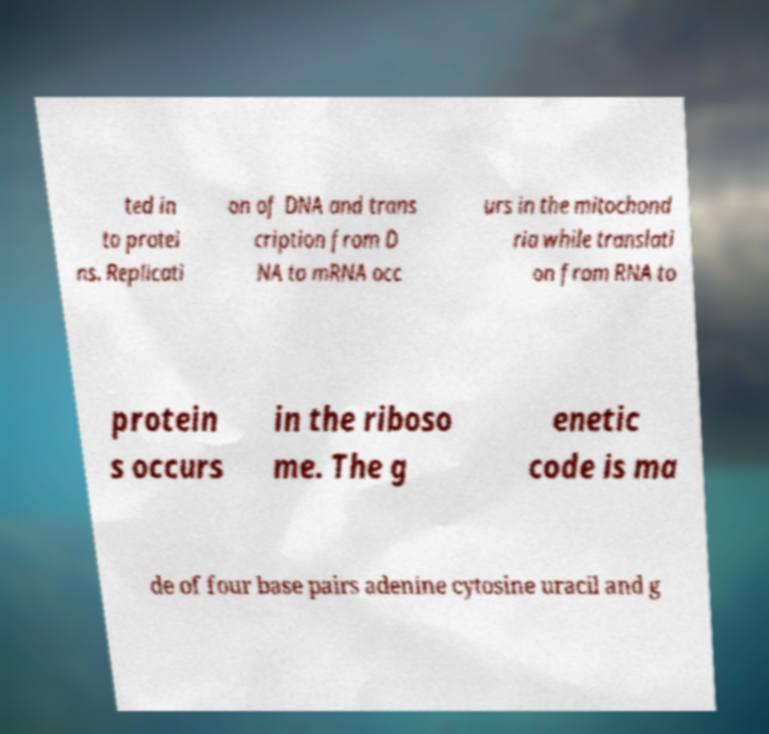Could you extract and type out the text from this image? ted in to protei ns. Replicati on of DNA and trans cription from D NA to mRNA occ urs in the mitochond ria while translati on from RNA to protein s occurs in the riboso me. The g enetic code is ma de of four base pairs adenine cytosine uracil and g 